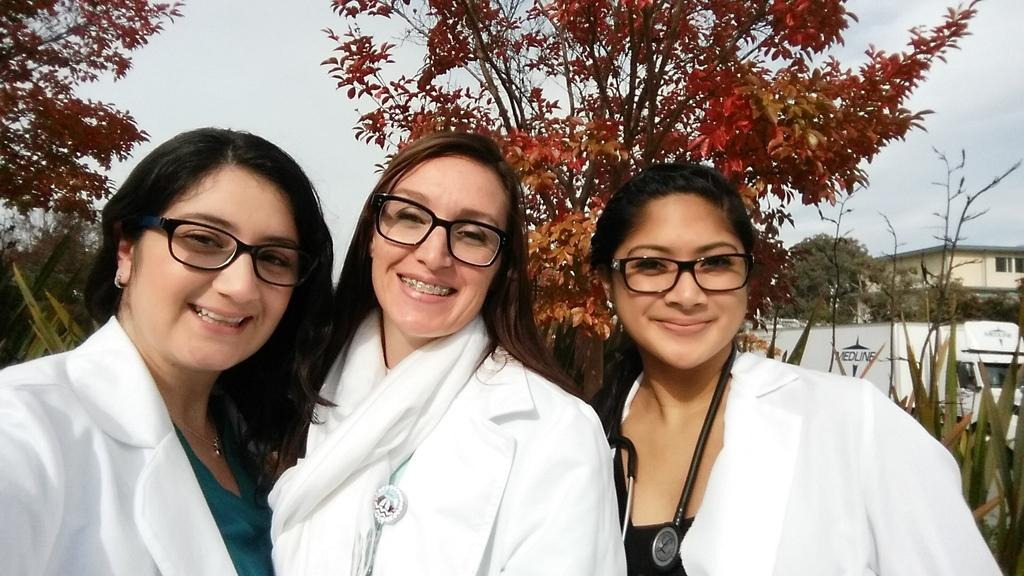How many women are in the image? There are three women in the image. What are the women wearing? The women are wearing white coats and spectacles. What is the facial expression of the women? The women are smiling. What can be seen in the background of the image? There is a vehicle, trees, a house, and the sky visible in the background of the image. What type of debt is the woman on the left discussing with her daughter in the image? There is no indication in the image that the women are discussing debt or that there is a daughter present. 